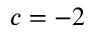<formula> <loc_0><loc_0><loc_500><loc_500>c = - 2</formula> 